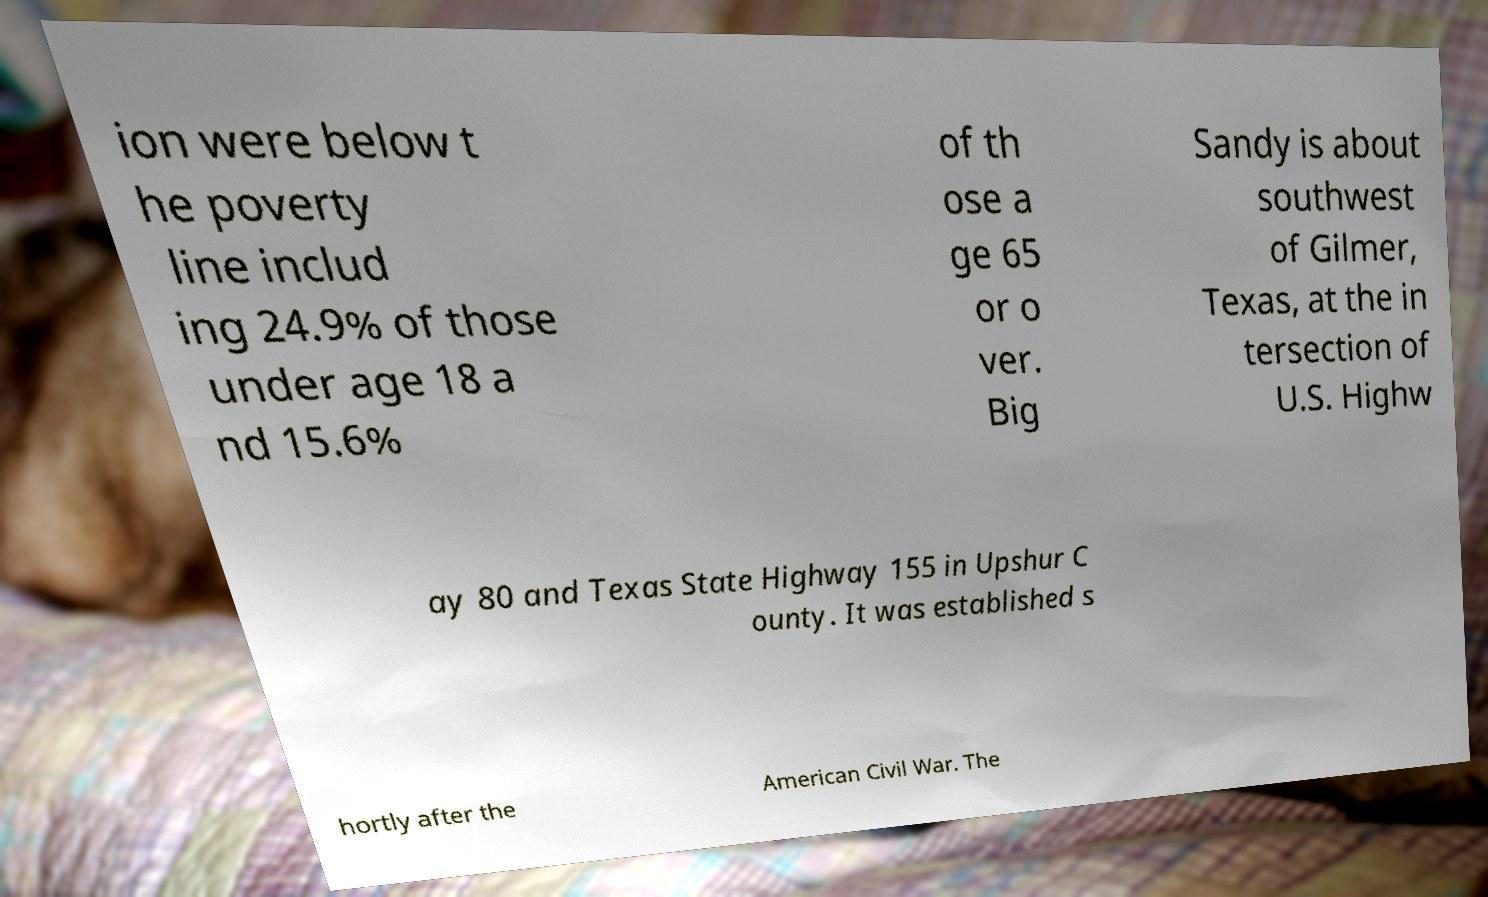What messages or text are displayed in this image? I need them in a readable, typed format. ion were below t he poverty line includ ing 24.9% of those under age 18 a nd 15.6% of th ose a ge 65 or o ver. Big Sandy is about southwest of Gilmer, Texas, at the in tersection of U.S. Highw ay 80 and Texas State Highway 155 in Upshur C ounty. It was established s hortly after the American Civil War. The 